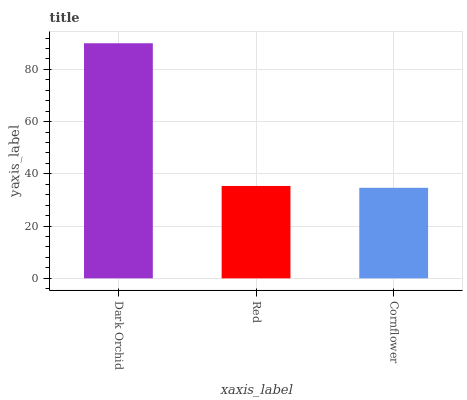Is Cornflower the minimum?
Answer yes or no. Yes. Is Dark Orchid the maximum?
Answer yes or no. Yes. Is Red the minimum?
Answer yes or no. No. Is Red the maximum?
Answer yes or no. No. Is Dark Orchid greater than Red?
Answer yes or no. Yes. Is Red less than Dark Orchid?
Answer yes or no. Yes. Is Red greater than Dark Orchid?
Answer yes or no. No. Is Dark Orchid less than Red?
Answer yes or no. No. Is Red the high median?
Answer yes or no. Yes. Is Red the low median?
Answer yes or no. Yes. Is Cornflower the high median?
Answer yes or no. No. Is Cornflower the low median?
Answer yes or no. No. 